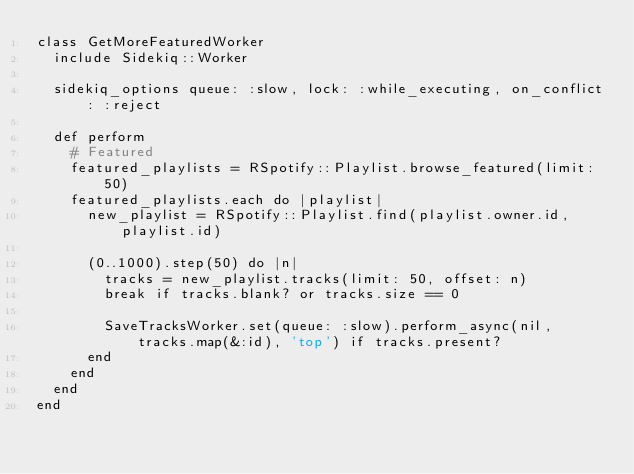<code> <loc_0><loc_0><loc_500><loc_500><_Ruby_>class GetMoreFeaturedWorker
  include Sidekiq::Worker

  sidekiq_options queue: :slow, lock: :while_executing, on_conflict: :reject

  def perform
    # Featured
    featured_playlists = RSpotify::Playlist.browse_featured(limit: 50)
    featured_playlists.each do |playlist|
      new_playlist = RSpotify::Playlist.find(playlist.owner.id, playlist.id)
      
      (0..1000).step(50) do |n|
        tracks = new_playlist.tracks(limit: 50, offset: n)
        break if tracks.blank? or tracks.size == 0

        SaveTracksWorker.set(queue: :slow).perform_async(nil, tracks.map(&:id), 'top') if tracks.present?
      end
    end
  end
end
</code> 